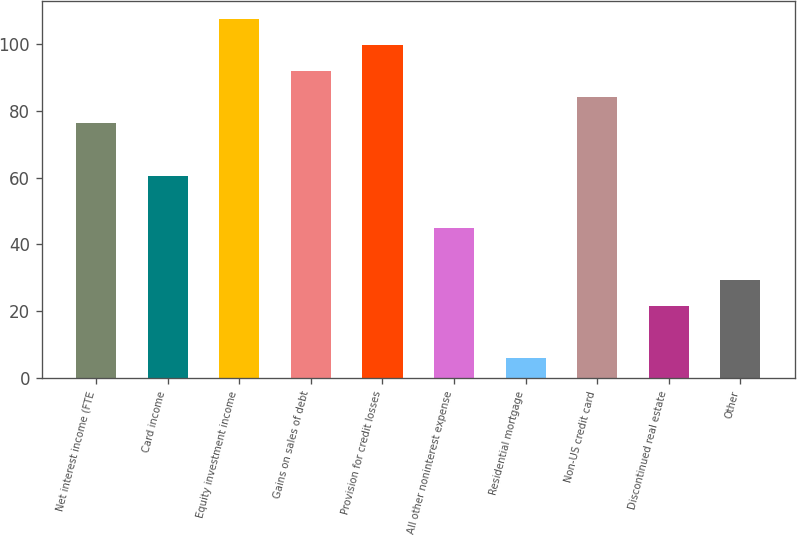Convert chart to OTSL. <chart><loc_0><loc_0><loc_500><loc_500><bar_chart><fcel>Net interest income (FTE<fcel>Card income<fcel>Equity investment income<fcel>Gains on sales of debt<fcel>Provision for credit losses<fcel>All other noninterest expense<fcel>Residential mortgage<fcel>Non-US credit card<fcel>Discontinued real estate<fcel>Other<nl><fcel>76.2<fcel>60.6<fcel>107.4<fcel>91.8<fcel>99.6<fcel>45<fcel>6<fcel>84<fcel>21.6<fcel>29.4<nl></chart> 